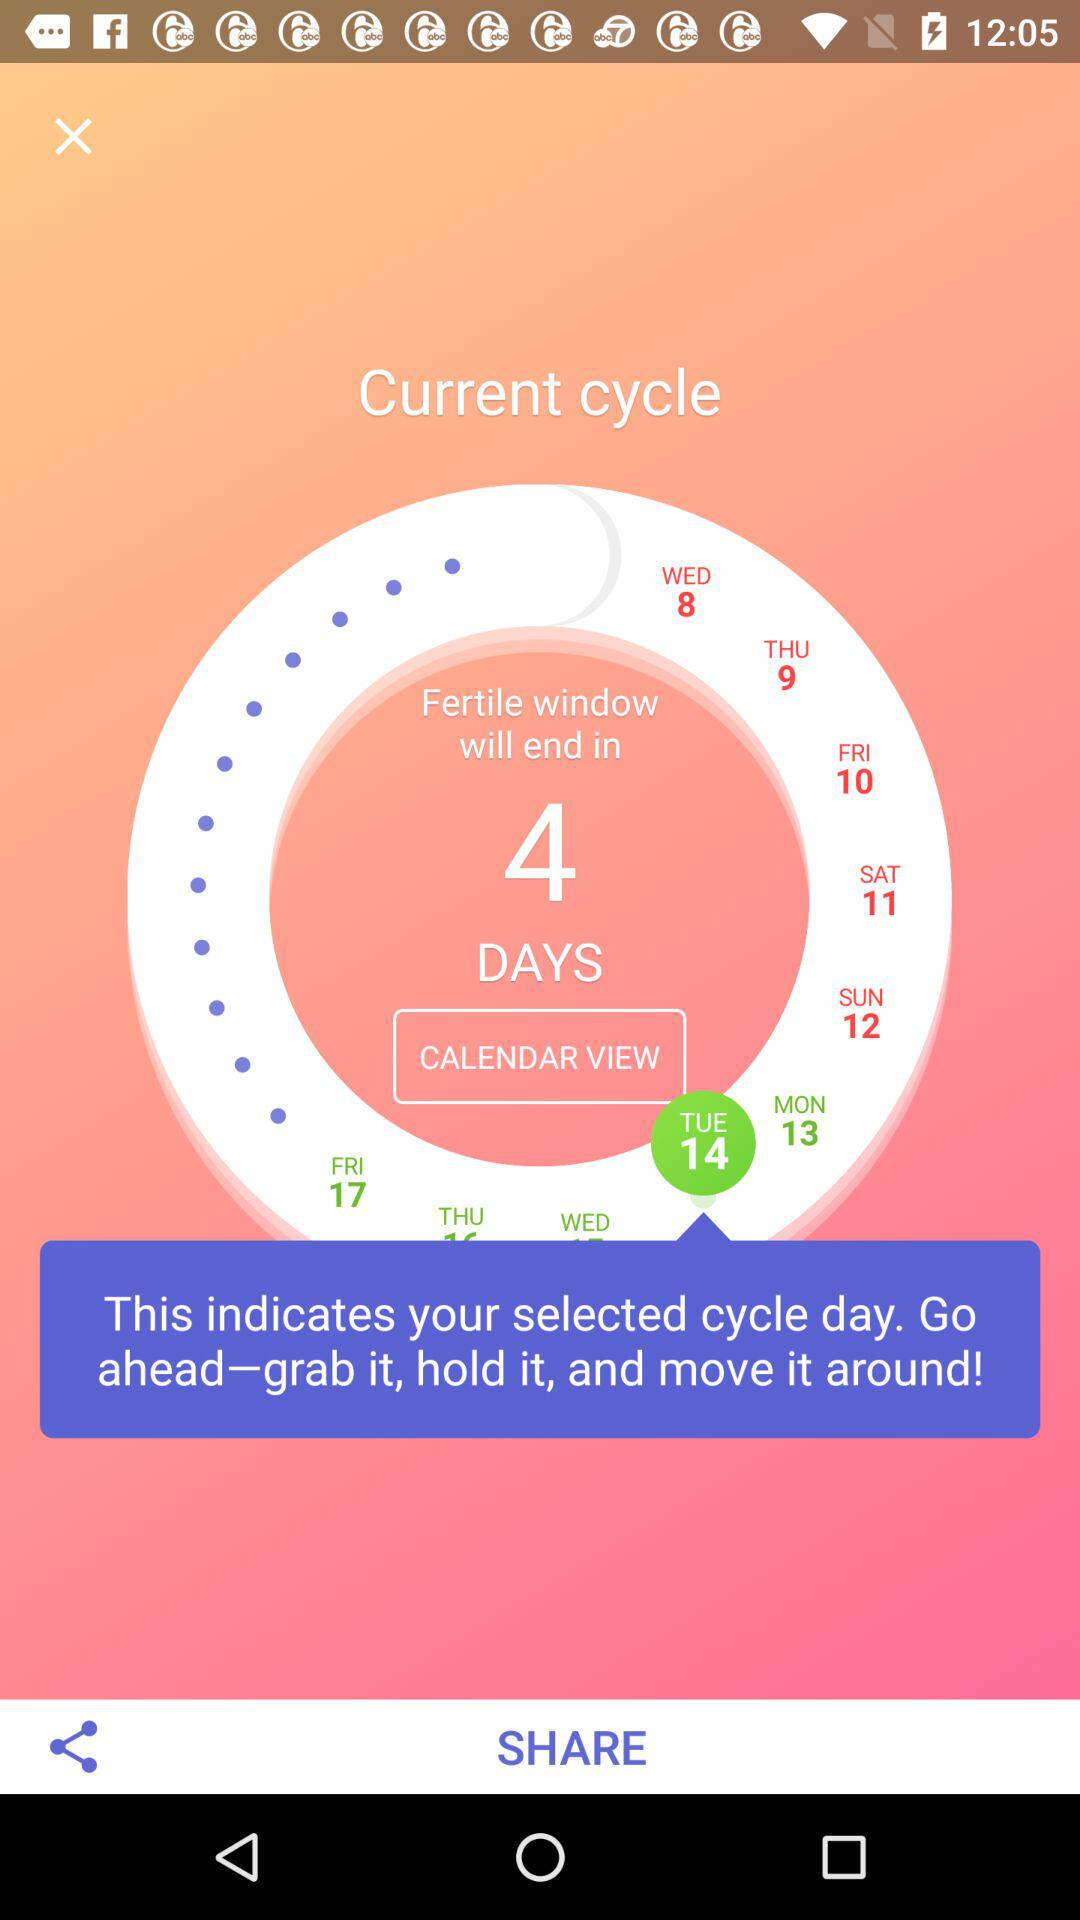Which date is selected? The selected date is Tuesday, 14. 